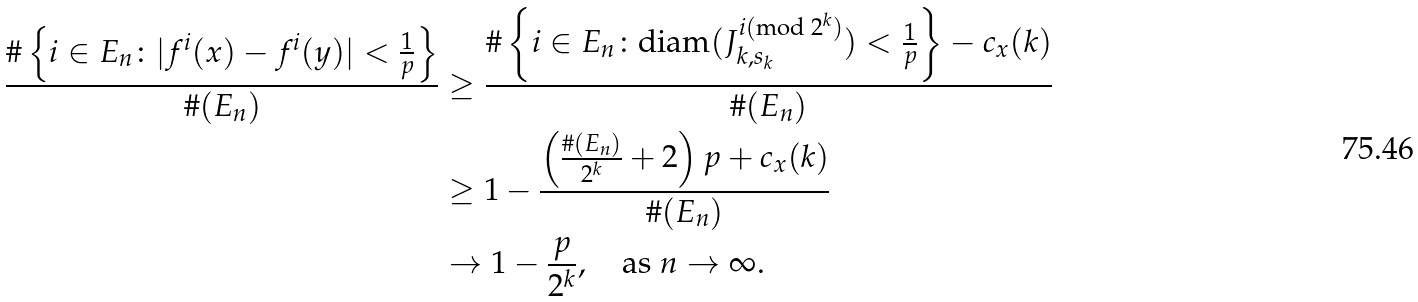Convert formula to latex. <formula><loc_0><loc_0><loc_500><loc_500>\frac { \# \left \{ i \in E _ { n } \colon | f ^ { i } ( x ) - f ^ { i } ( y ) | < \frac { 1 } { p } \right \} } { \# ( E _ { n } ) } & \geq \frac { \# \left \{ i \in E _ { n } \colon \text {diam} ( J _ { k , s _ { k } } ^ { i ( \text {mod } 2 ^ { k } ) } ) < \frac { 1 } { p } \right \} - c _ { x } ( k ) } { \# ( E _ { n } ) } \\ & \geq 1 - \frac { \left ( \frac { \# ( E _ { n } ) } { 2 ^ { k } } + 2 \right ) p + c _ { x } ( k ) } { \# ( E _ { n } ) } \\ & \to 1 - \frac { p } { 2 ^ { k } } , \quad \text {as } n \to \infty .</formula> 